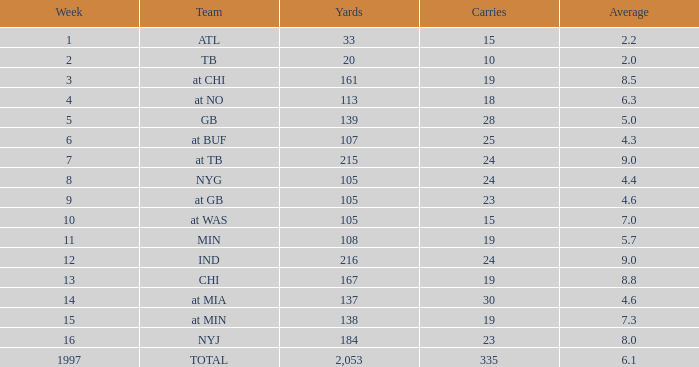Which Average has Yards larger than 167, and a Team of at tb, and a Week larger than 7? None. 